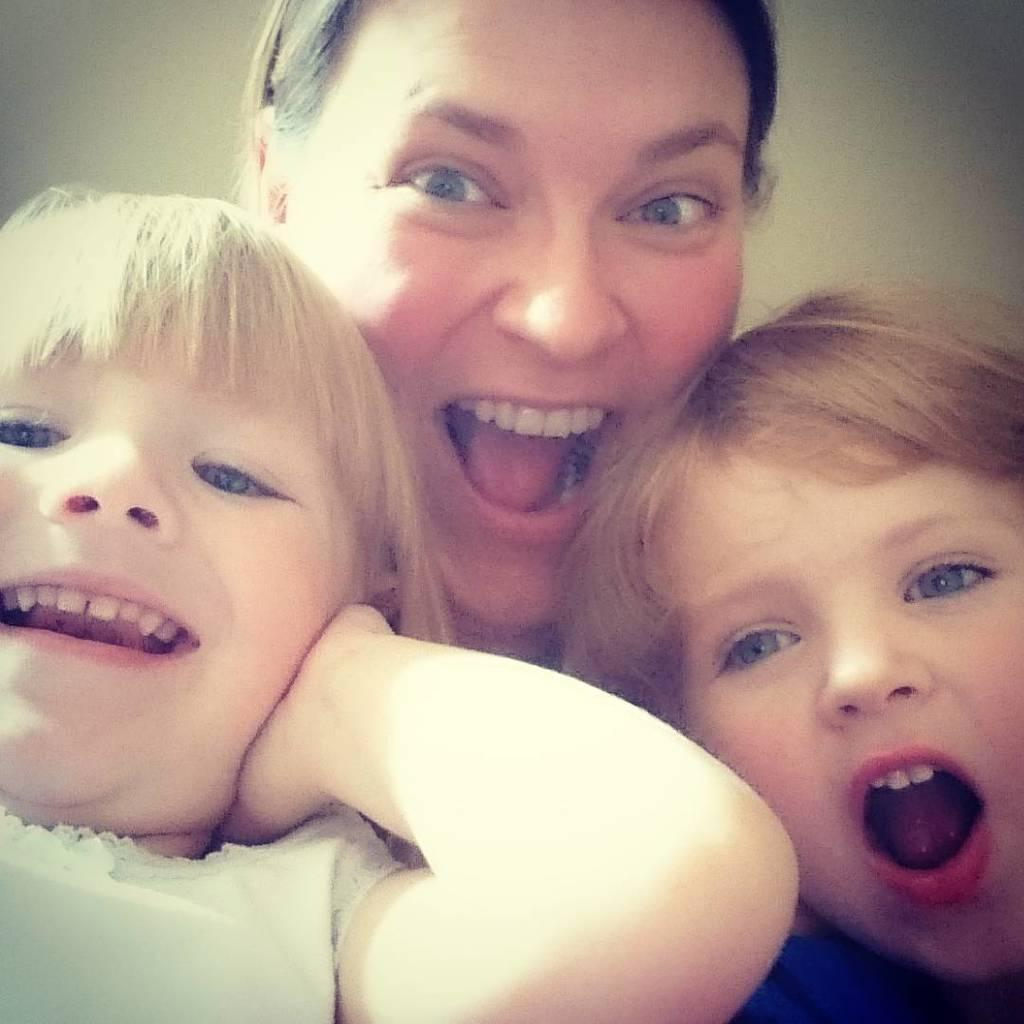How many people are in the image? There are three persons in the image. Can you describe the individuals in the image? One of the persons is a woman, and the other two persons are children. Where was the image taken? The image appears to be taken in a room. What can be seen in the background of the image? There is a wall visible in the background of the image. What type of powder can be seen on the floor in the image? There is no powder visible on the floor in the image. 